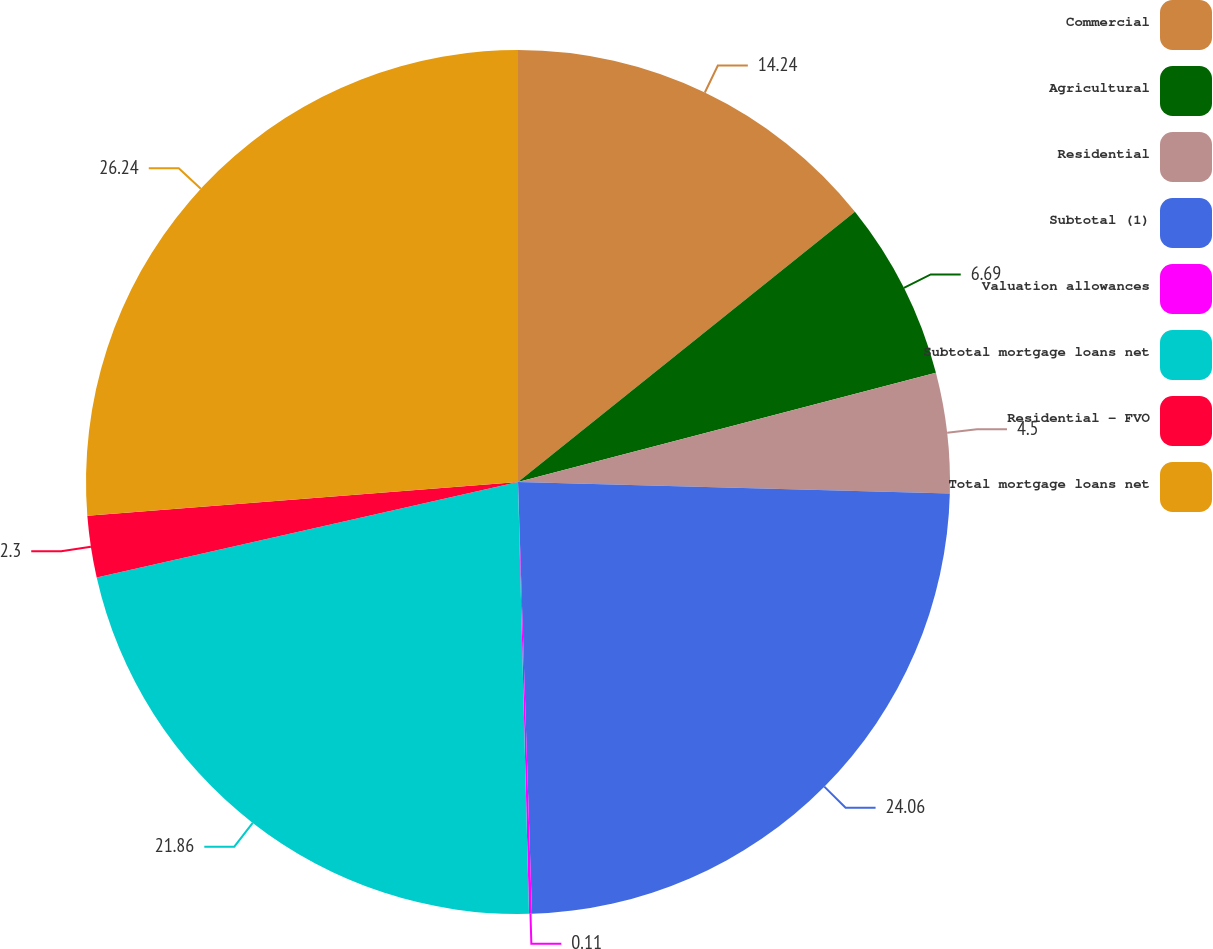Convert chart to OTSL. <chart><loc_0><loc_0><loc_500><loc_500><pie_chart><fcel>Commercial<fcel>Agricultural<fcel>Residential<fcel>Subtotal (1)<fcel>Valuation allowances<fcel>Subtotal mortgage loans net<fcel>Residential - FVO<fcel>Total mortgage loans net<nl><fcel>14.24%<fcel>6.69%<fcel>4.5%<fcel>24.06%<fcel>0.11%<fcel>21.86%<fcel>2.3%<fcel>26.25%<nl></chart> 